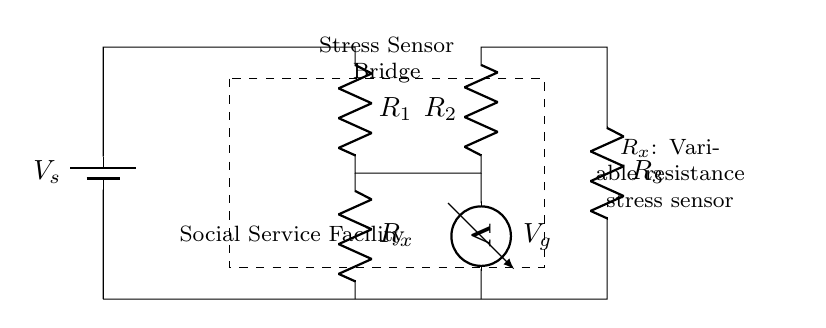What is the type of the variable resistance in the circuit? The variable resistance is identified as R_x, labeled in the diagram, and it specifies that it is a stress sensor.
Answer: stress sensor What components are used in the bridge circuit? The bridge circuit includes three resistors R_1, R_2, and R_3, and a variable resistor R_x associated with the stress sensor.
Answer: R_1, R_2, R_3, R_x What is the function of the voltmeter in the circuit? The voltmeter measures the voltage across the points where it is connected in the circuit, specifically across R_x, which allows for monitoring of changes in resistance.
Answer: measure voltage changes How many resistors are in the circuit? The circuit has four resistors: three fixed resistors (R_1, R_2, R_3) and one variable resistor (R_x).
Answer: four Why is the bridge circuit configuration used for the stress sensor? The bridge configuration allows for precise measurement of the changes in resistance of the stress sensor (R_x) in response to deformation, enhancing sensitivity and accuracy.
Answer: precise measurement What is the purpose of the dashed rectangle in the diagram? The dashed rectangle indicates the area of the bridge circuit specifically dedicated to the stress sensor, highlighting its function within the overall circuit structure.
Answer: indicates stress sensor area 